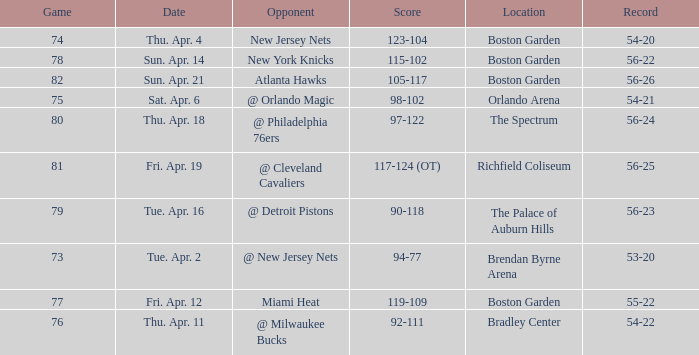When was the score 56-26? Sun. Apr. 21. Could you parse the entire table as a dict? {'header': ['Game', 'Date', 'Opponent', 'Score', 'Location', 'Record'], 'rows': [['74', 'Thu. Apr. 4', 'New Jersey Nets', '123-104', 'Boston Garden', '54-20'], ['78', 'Sun. Apr. 14', 'New York Knicks', '115-102', 'Boston Garden', '56-22'], ['82', 'Sun. Apr. 21', 'Atlanta Hawks', '105-117', 'Boston Garden', '56-26'], ['75', 'Sat. Apr. 6', '@ Orlando Magic', '98-102', 'Orlando Arena', '54-21'], ['80', 'Thu. Apr. 18', '@ Philadelphia 76ers', '97-122', 'The Spectrum', '56-24'], ['81', 'Fri. Apr. 19', '@ Cleveland Cavaliers', '117-124 (OT)', 'Richfield Coliseum', '56-25'], ['79', 'Tue. Apr. 16', '@ Detroit Pistons', '90-118', 'The Palace of Auburn Hills', '56-23'], ['73', 'Tue. Apr. 2', '@ New Jersey Nets', '94-77', 'Brendan Byrne Arena', '53-20'], ['77', 'Fri. Apr. 12', 'Miami Heat', '119-109', 'Boston Garden', '55-22'], ['76', 'Thu. Apr. 11', '@ Milwaukee Bucks', '92-111', 'Bradley Center', '54-22']]} 